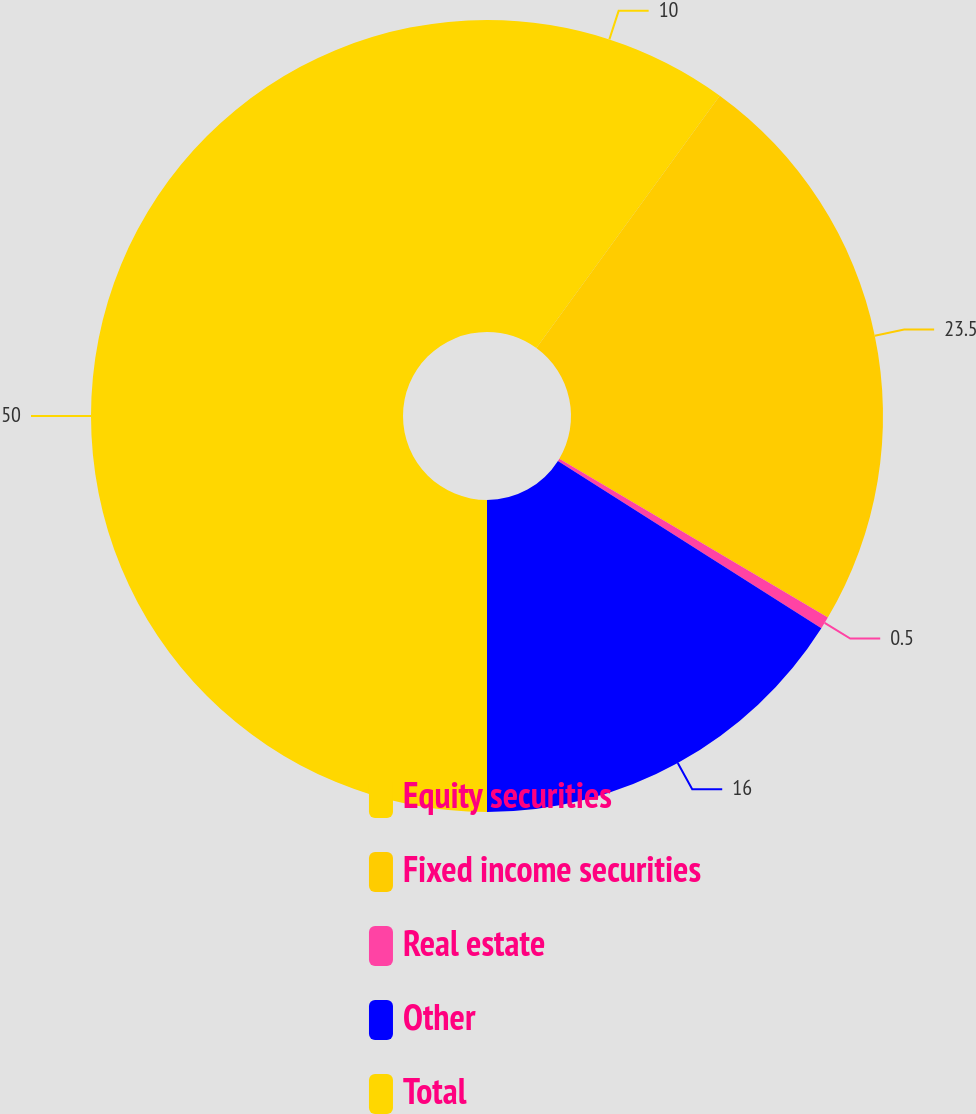Convert chart to OTSL. <chart><loc_0><loc_0><loc_500><loc_500><pie_chart><fcel>Equity securities<fcel>Fixed income securities<fcel>Real estate<fcel>Other<fcel>Total<nl><fcel>10.0%<fcel>23.5%<fcel>0.5%<fcel>16.0%<fcel>50.0%<nl></chart> 